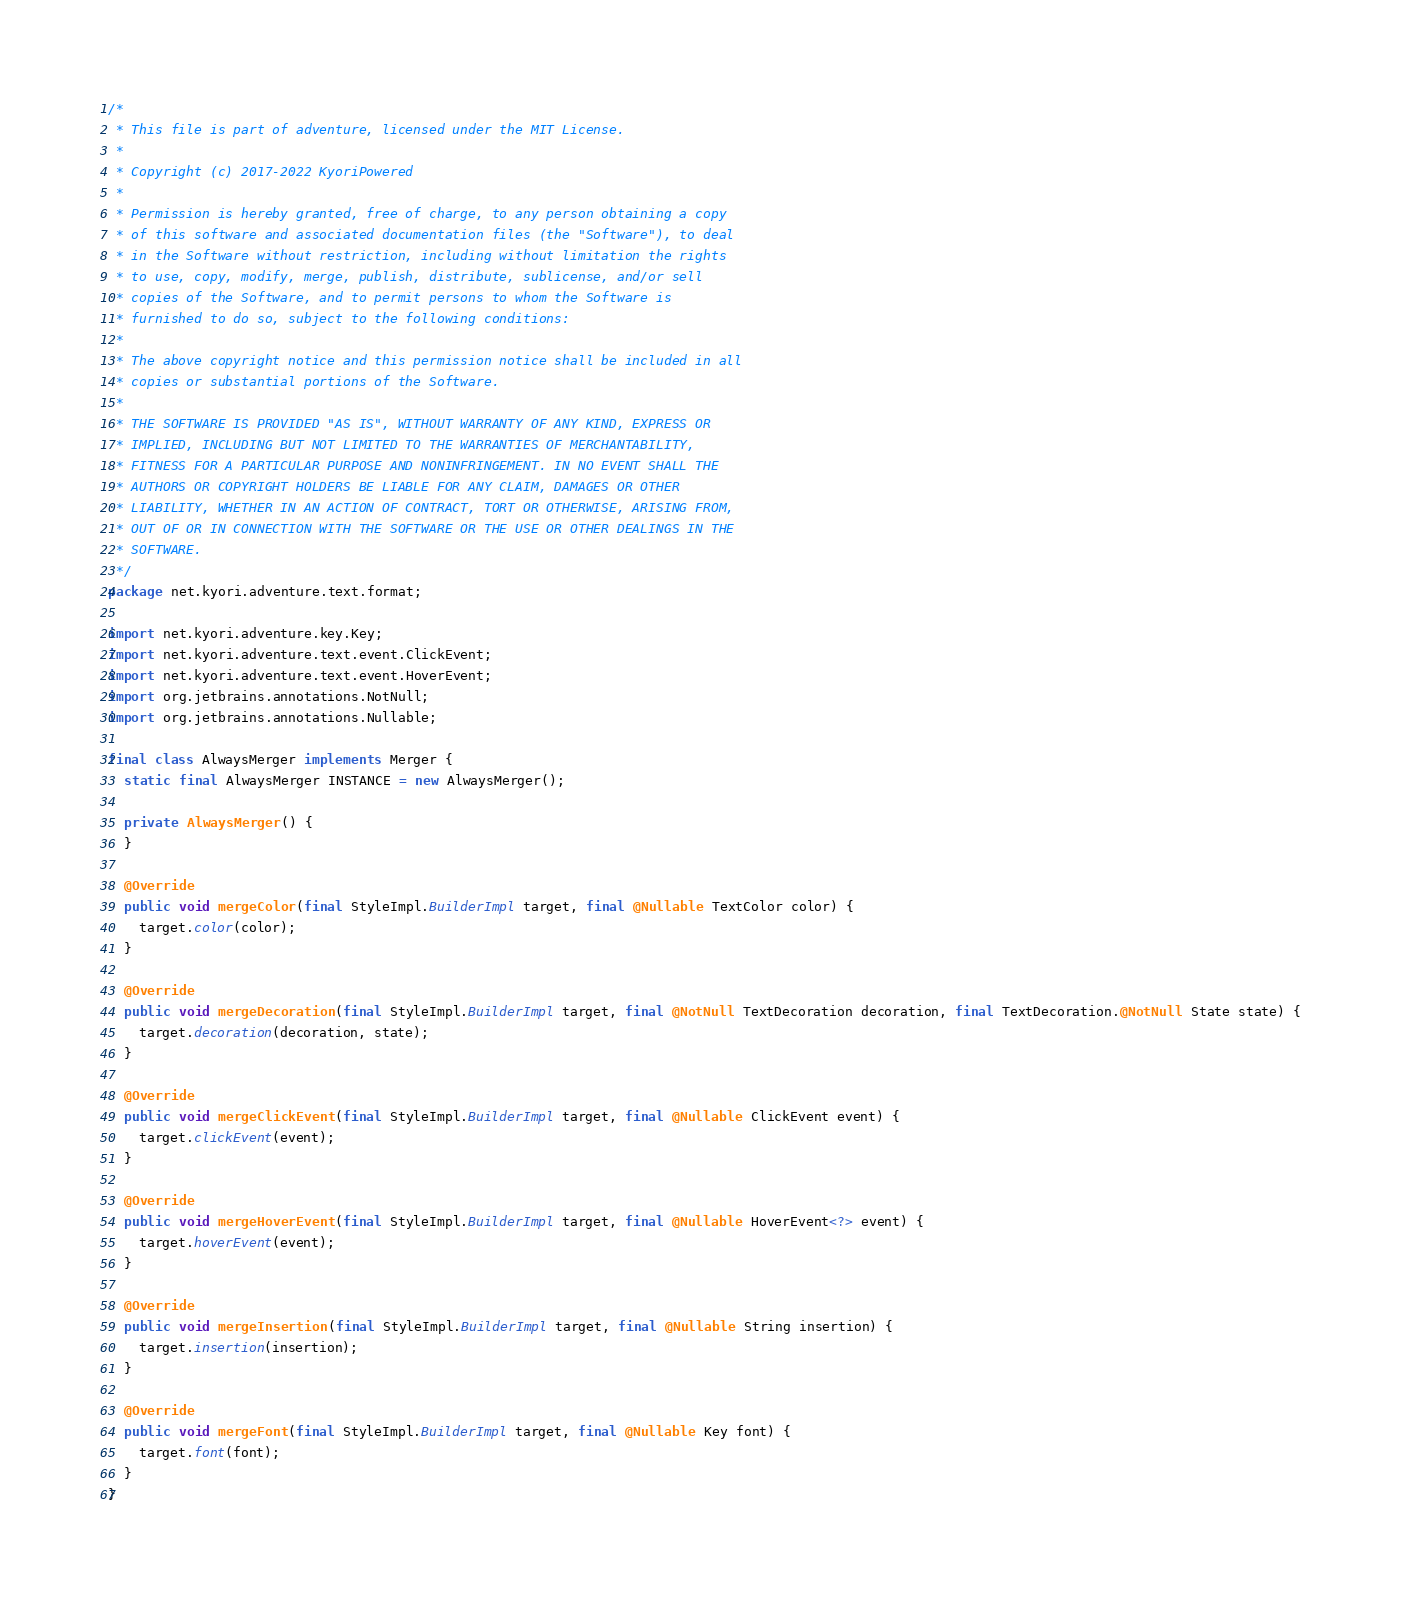Convert code to text. <code><loc_0><loc_0><loc_500><loc_500><_Java_>/*
 * This file is part of adventure, licensed under the MIT License.
 *
 * Copyright (c) 2017-2022 KyoriPowered
 *
 * Permission is hereby granted, free of charge, to any person obtaining a copy
 * of this software and associated documentation files (the "Software"), to deal
 * in the Software without restriction, including without limitation the rights
 * to use, copy, modify, merge, publish, distribute, sublicense, and/or sell
 * copies of the Software, and to permit persons to whom the Software is
 * furnished to do so, subject to the following conditions:
 *
 * The above copyright notice and this permission notice shall be included in all
 * copies or substantial portions of the Software.
 *
 * THE SOFTWARE IS PROVIDED "AS IS", WITHOUT WARRANTY OF ANY KIND, EXPRESS OR
 * IMPLIED, INCLUDING BUT NOT LIMITED TO THE WARRANTIES OF MERCHANTABILITY,
 * FITNESS FOR A PARTICULAR PURPOSE AND NONINFRINGEMENT. IN NO EVENT SHALL THE
 * AUTHORS OR COPYRIGHT HOLDERS BE LIABLE FOR ANY CLAIM, DAMAGES OR OTHER
 * LIABILITY, WHETHER IN AN ACTION OF CONTRACT, TORT OR OTHERWISE, ARISING FROM,
 * OUT OF OR IN CONNECTION WITH THE SOFTWARE OR THE USE OR OTHER DEALINGS IN THE
 * SOFTWARE.
 */
package net.kyori.adventure.text.format;

import net.kyori.adventure.key.Key;
import net.kyori.adventure.text.event.ClickEvent;
import net.kyori.adventure.text.event.HoverEvent;
import org.jetbrains.annotations.NotNull;
import org.jetbrains.annotations.Nullable;

final class AlwaysMerger implements Merger {
  static final AlwaysMerger INSTANCE = new AlwaysMerger();

  private AlwaysMerger() {
  }

  @Override
  public void mergeColor(final StyleImpl.BuilderImpl target, final @Nullable TextColor color) {
    target.color(color);
  }

  @Override
  public void mergeDecoration(final StyleImpl.BuilderImpl target, final @NotNull TextDecoration decoration, final TextDecoration.@NotNull State state) {
    target.decoration(decoration, state);
  }

  @Override
  public void mergeClickEvent(final StyleImpl.BuilderImpl target, final @Nullable ClickEvent event) {
    target.clickEvent(event);
  }

  @Override
  public void mergeHoverEvent(final StyleImpl.BuilderImpl target, final @Nullable HoverEvent<?> event) {
    target.hoverEvent(event);
  }

  @Override
  public void mergeInsertion(final StyleImpl.BuilderImpl target, final @Nullable String insertion) {
    target.insertion(insertion);
  }

  @Override
  public void mergeFont(final StyleImpl.BuilderImpl target, final @Nullable Key font) {
    target.font(font);
  }
}
</code> 